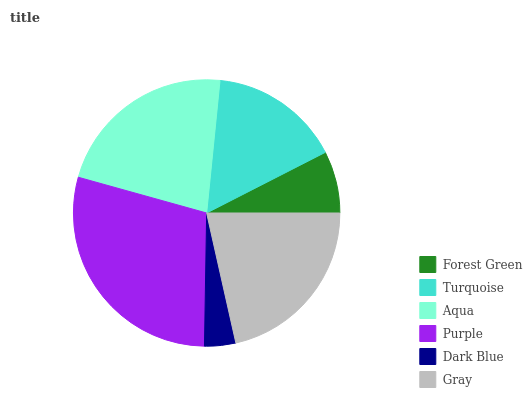Is Dark Blue the minimum?
Answer yes or no. Yes. Is Purple the maximum?
Answer yes or no. Yes. Is Turquoise the minimum?
Answer yes or no. No. Is Turquoise the maximum?
Answer yes or no. No. Is Turquoise greater than Forest Green?
Answer yes or no. Yes. Is Forest Green less than Turquoise?
Answer yes or no. Yes. Is Forest Green greater than Turquoise?
Answer yes or no. No. Is Turquoise less than Forest Green?
Answer yes or no. No. Is Gray the high median?
Answer yes or no. Yes. Is Turquoise the low median?
Answer yes or no. Yes. Is Aqua the high median?
Answer yes or no. No. Is Purple the low median?
Answer yes or no. No. 